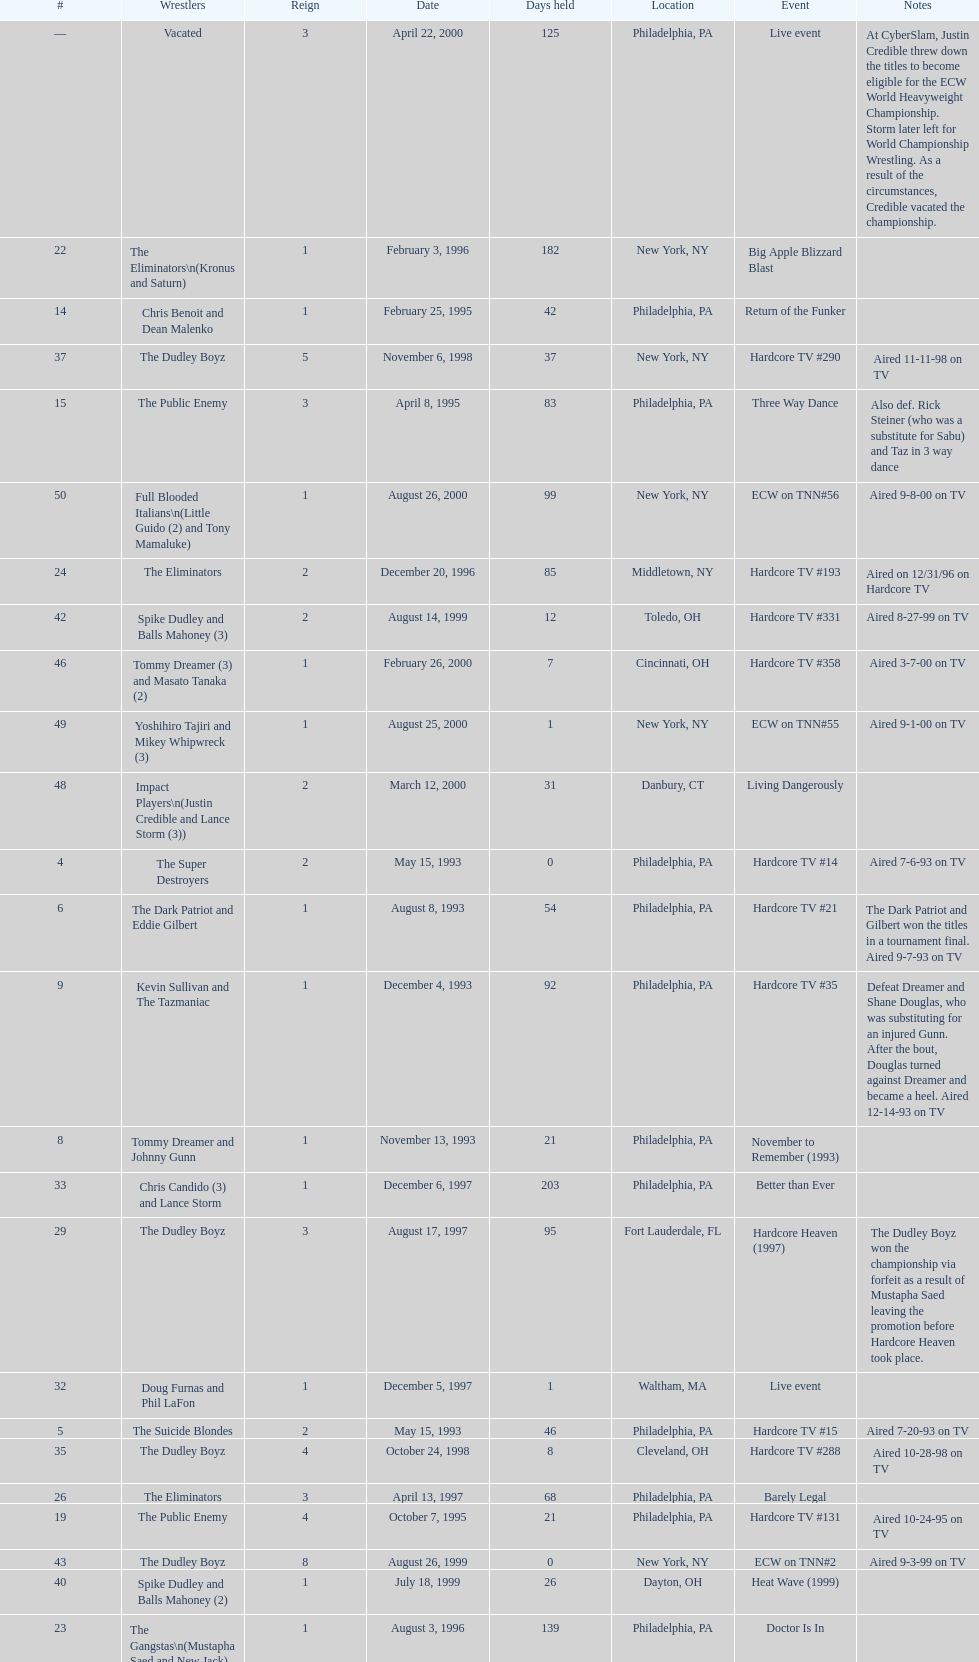How many times, from june 23, 1992 to december 3, 2000, did the suicide blondes hold the title? 2. 